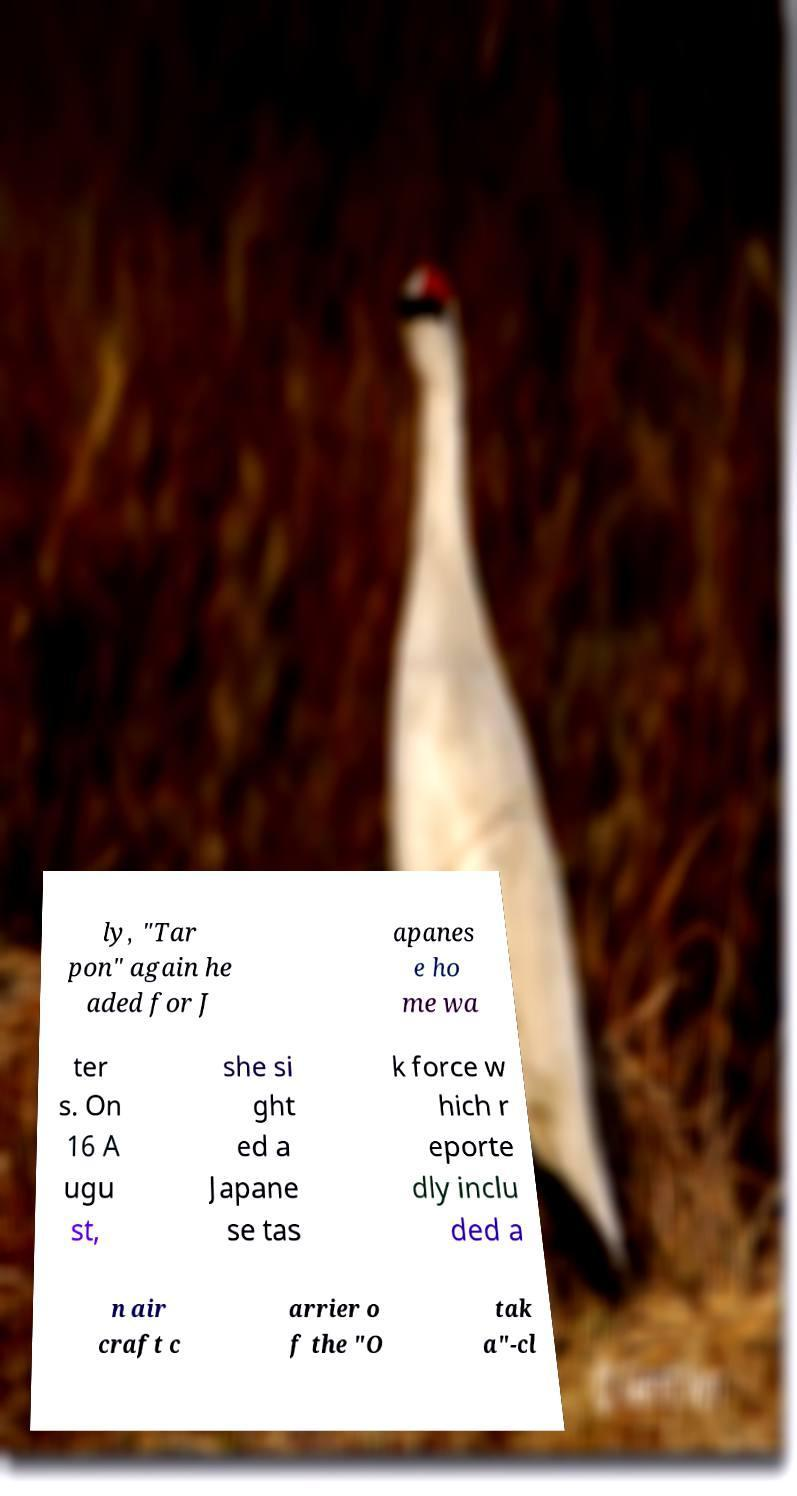What messages or text are displayed in this image? I need them in a readable, typed format. ly, "Tar pon" again he aded for J apanes e ho me wa ter s. On 16 A ugu st, she si ght ed a Japane se tas k force w hich r eporte dly inclu ded a n air craft c arrier o f the "O tak a"-cl 